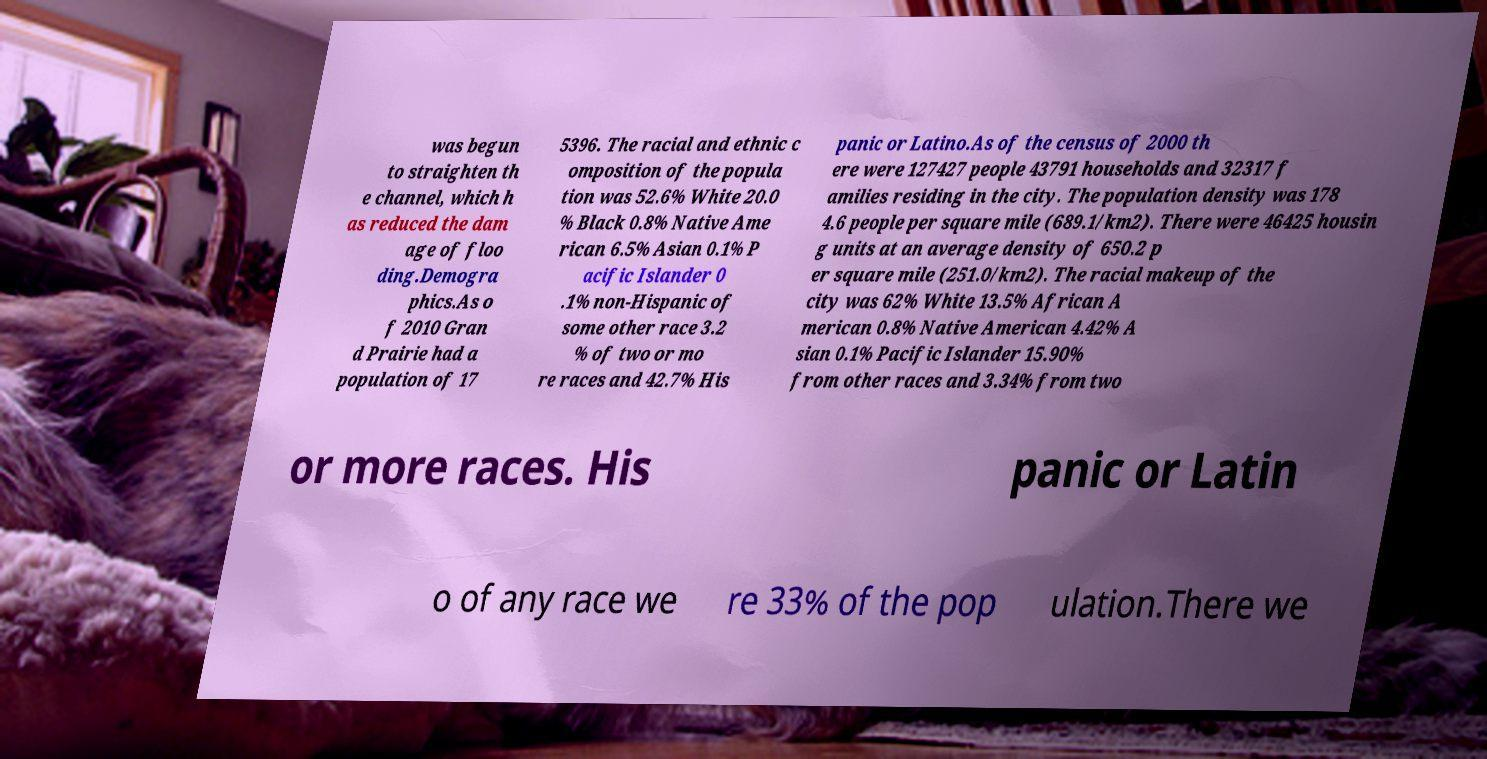Please read and relay the text visible in this image. What does it say? was begun to straighten th e channel, which h as reduced the dam age of floo ding.Demogra phics.As o f 2010 Gran d Prairie had a population of 17 5396. The racial and ethnic c omposition of the popula tion was 52.6% White 20.0 % Black 0.8% Native Ame rican 6.5% Asian 0.1% P acific Islander 0 .1% non-Hispanic of some other race 3.2 % of two or mo re races and 42.7% His panic or Latino.As of the census of 2000 th ere were 127427 people 43791 households and 32317 f amilies residing in the city. The population density was 178 4.6 people per square mile (689.1/km2). There were 46425 housin g units at an average density of 650.2 p er square mile (251.0/km2). The racial makeup of the city was 62% White 13.5% African A merican 0.8% Native American 4.42% A sian 0.1% Pacific Islander 15.90% from other races and 3.34% from two or more races. His panic or Latin o of any race we re 33% of the pop ulation.There we 